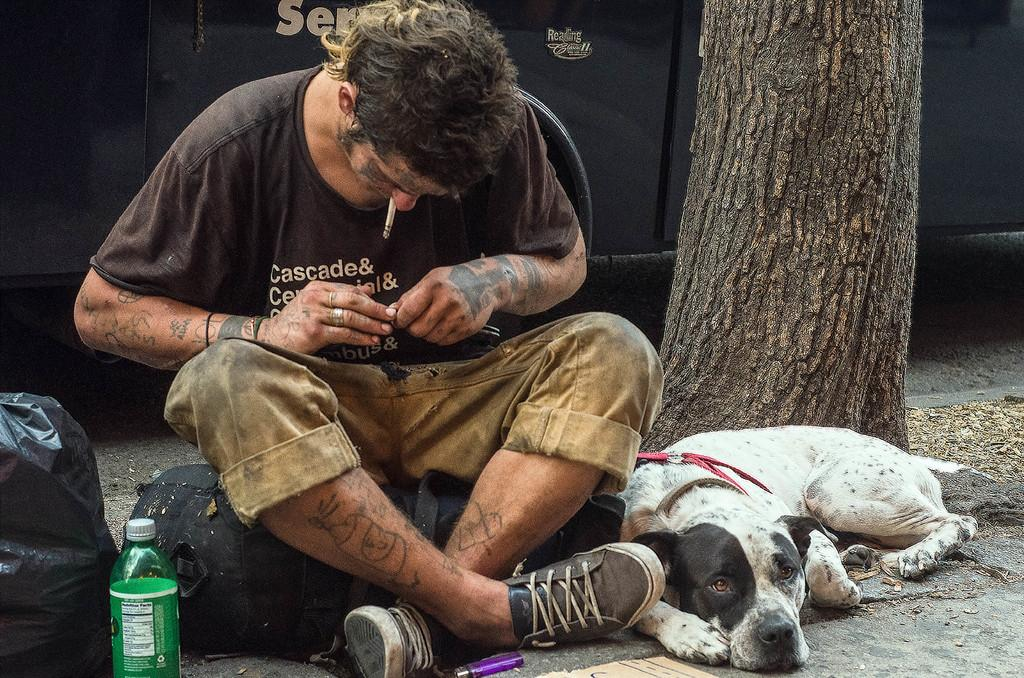What is the main object in the image? There is a tree stem in the image. Are there any living creatures in the image? Yes, there is a dog in the image. What is the man in the image doing? The man is sitting in the image. What can be seen on the left side of the image? There is a black color cover and a bottle on the left side of the image. What type of brass instrument is the dog playing in the image? There is no brass instrument present in the image, and the dog is not playing any instrument. How many kittens are sitting on the man's lap in the image? There are no kittens present in the image, and no kittens are sitting on the man's lap. 